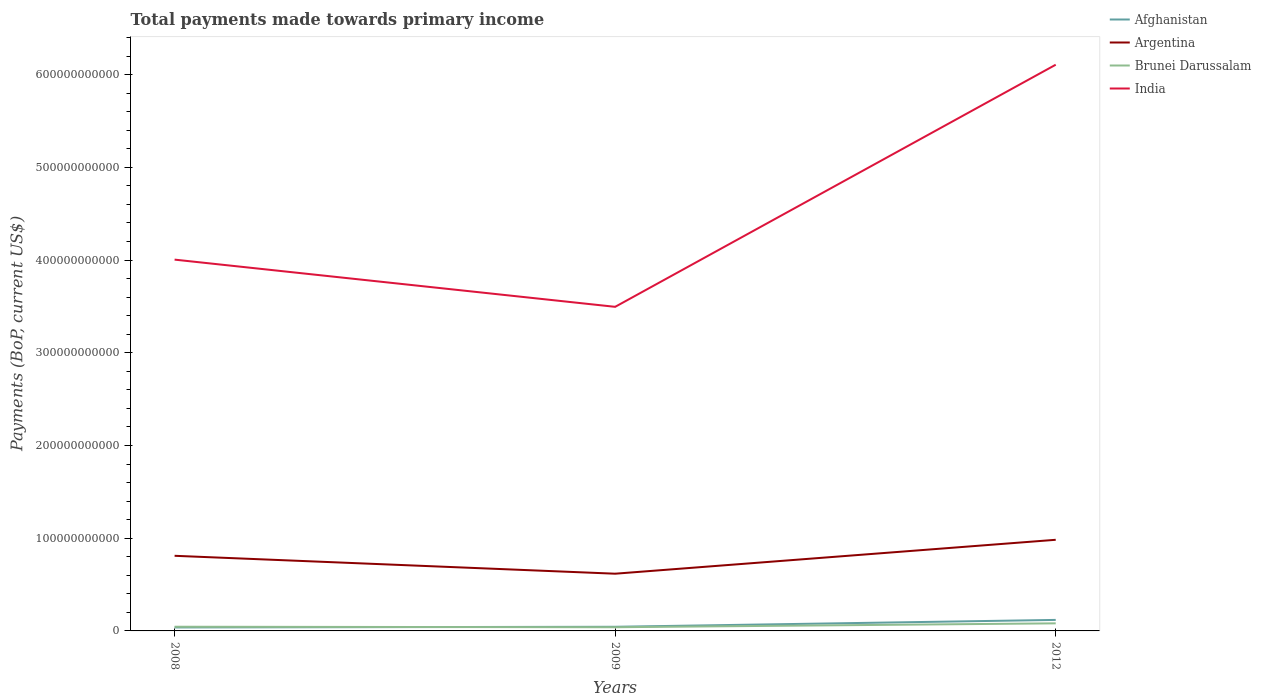How many different coloured lines are there?
Offer a terse response. 4. Across all years, what is the maximum total payments made towards primary income in India?
Give a very brief answer. 3.50e+11. In which year was the total payments made towards primary income in Afghanistan maximum?
Provide a succinct answer. 2008. What is the total total payments made towards primary income in Brunei Darussalam in the graph?
Give a very brief answer. 5.28e+08. What is the difference between the highest and the second highest total payments made towards primary income in Argentina?
Make the answer very short. 3.66e+1. What is the difference between the highest and the lowest total payments made towards primary income in Argentina?
Keep it short and to the point. 2. Is the total payments made towards primary income in India strictly greater than the total payments made towards primary income in Afghanistan over the years?
Keep it short and to the point. No. What is the difference between two consecutive major ticks on the Y-axis?
Your answer should be compact. 1.00e+11. Are the values on the major ticks of Y-axis written in scientific E-notation?
Your response must be concise. No. Does the graph contain any zero values?
Offer a terse response. No. Does the graph contain grids?
Your answer should be compact. No. Where does the legend appear in the graph?
Offer a very short reply. Top right. How many legend labels are there?
Your answer should be compact. 4. How are the legend labels stacked?
Offer a terse response. Vertical. What is the title of the graph?
Give a very brief answer. Total payments made towards primary income. Does "Belgium" appear as one of the legend labels in the graph?
Keep it short and to the point. No. What is the label or title of the X-axis?
Provide a short and direct response. Years. What is the label or title of the Y-axis?
Give a very brief answer. Payments (BoP, current US$). What is the Payments (BoP, current US$) of Afghanistan in 2008?
Keep it short and to the point. 3.75e+09. What is the Payments (BoP, current US$) in Argentina in 2008?
Make the answer very short. 8.10e+1. What is the Payments (BoP, current US$) of Brunei Darussalam in 2008?
Give a very brief answer. 4.51e+09. What is the Payments (BoP, current US$) of India in 2008?
Make the answer very short. 4.00e+11. What is the Payments (BoP, current US$) in Afghanistan in 2009?
Ensure brevity in your answer.  4.47e+09. What is the Payments (BoP, current US$) of Argentina in 2009?
Your response must be concise. 6.17e+1. What is the Payments (BoP, current US$) of Brunei Darussalam in 2009?
Your response must be concise. 3.98e+09. What is the Payments (BoP, current US$) of India in 2009?
Provide a succinct answer. 3.50e+11. What is the Payments (BoP, current US$) of Afghanistan in 2012?
Offer a terse response. 1.19e+1. What is the Payments (BoP, current US$) in Argentina in 2012?
Offer a very short reply. 9.83e+1. What is the Payments (BoP, current US$) of Brunei Darussalam in 2012?
Provide a short and direct response. 8.18e+09. What is the Payments (BoP, current US$) of India in 2012?
Provide a succinct answer. 6.11e+11. Across all years, what is the maximum Payments (BoP, current US$) in Afghanistan?
Provide a succinct answer. 1.19e+1. Across all years, what is the maximum Payments (BoP, current US$) in Argentina?
Provide a succinct answer. 9.83e+1. Across all years, what is the maximum Payments (BoP, current US$) in Brunei Darussalam?
Provide a short and direct response. 8.18e+09. Across all years, what is the maximum Payments (BoP, current US$) of India?
Ensure brevity in your answer.  6.11e+11. Across all years, what is the minimum Payments (BoP, current US$) in Afghanistan?
Make the answer very short. 3.75e+09. Across all years, what is the minimum Payments (BoP, current US$) in Argentina?
Offer a very short reply. 6.17e+1. Across all years, what is the minimum Payments (BoP, current US$) of Brunei Darussalam?
Your answer should be very brief. 3.98e+09. Across all years, what is the minimum Payments (BoP, current US$) of India?
Give a very brief answer. 3.50e+11. What is the total Payments (BoP, current US$) in Afghanistan in the graph?
Your answer should be very brief. 2.01e+1. What is the total Payments (BoP, current US$) of Argentina in the graph?
Keep it short and to the point. 2.41e+11. What is the total Payments (BoP, current US$) of Brunei Darussalam in the graph?
Give a very brief answer. 1.67e+1. What is the total Payments (BoP, current US$) in India in the graph?
Give a very brief answer. 1.36e+12. What is the difference between the Payments (BoP, current US$) of Afghanistan in 2008 and that in 2009?
Ensure brevity in your answer.  -7.15e+08. What is the difference between the Payments (BoP, current US$) in Argentina in 2008 and that in 2009?
Give a very brief answer. 1.93e+1. What is the difference between the Payments (BoP, current US$) in Brunei Darussalam in 2008 and that in 2009?
Your answer should be very brief. 5.28e+08. What is the difference between the Payments (BoP, current US$) in India in 2008 and that in 2009?
Ensure brevity in your answer.  5.09e+1. What is the difference between the Payments (BoP, current US$) in Afghanistan in 2008 and that in 2012?
Make the answer very short. -8.13e+09. What is the difference between the Payments (BoP, current US$) in Argentina in 2008 and that in 2012?
Offer a very short reply. -1.73e+1. What is the difference between the Payments (BoP, current US$) in Brunei Darussalam in 2008 and that in 2012?
Provide a succinct answer. -3.67e+09. What is the difference between the Payments (BoP, current US$) in India in 2008 and that in 2012?
Provide a short and direct response. -2.10e+11. What is the difference between the Payments (BoP, current US$) in Afghanistan in 2009 and that in 2012?
Make the answer very short. -7.42e+09. What is the difference between the Payments (BoP, current US$) of Argentina in 2009 and that in 2012?
Give a very brief answer. -3.66e+1. What is the difference between the Payments (BoP, current US$) in Brunei Darussalam in 2009 and that in 2012?
Offer a terse response. -4.20e+09. What is the difference between the Payments (BoP, current US$) of India in 2009 and that in 2012?
Provide a short and direct response. -2.61e+11. What is the difference between the Payments (BoP, current US$) of Afghanistan in 2008 and the Payments (BoP, current US$) of Argentina in 2009?
Offer a terse response. -5.80e+1. What is the difference between the Payments (BoP, current US$) in Afghanistan in 2008 and the Payments (BoP, current US$) in Brunei Darussalam in 2009?
Offer a very short reply. -2.29e+08. What is the difference between the Payments (BoP, current US$) in Afghanistan in 2008 and the Payments (BoP, current US$) in India in 2009?
Provide a succinct answer. -3.46e+11. What is the difference between the Payments (BoP, current US$) of Argentina in 2008 and the Payments (BoP, current US$) of Brunei Darussalam in 2009?
Your answer should be very brief. 7.70e+1. What is the difference between the Payments (BoP, current US$) in Argentina in 2008 and the Payments (BoP, current US$) in India in 2009?
Your answer should be compact. -2.69e+11. What is the difference between the Payments (BoP, current US$) of Brunei Darussalam in 2008 and the Payments (BoP, current US$) of India in 2009?
Make the answer very short. -3.45e+11. What is the difference between the Payments (BoP, current US$) of Afghanistan in 2008 and the Payments (BoP, current US$) of Argentina in 2012?
Provide a short and direct response. -9.45e+1. What is the difference between the Payments (BoP, current US$) in Afghanistan in 2008 and the Payments (BoP, current US$) in Brunei Darussalam in 2012?
Ensure brevity in your answer.  -4.43e+09. What is the difference between the Payments (BoP, current US$) in Afghanistan in 2008 and the Payments (BoP, current US$) in India in 2012?
Make the answer very short. -6.07e+11. What is the difference between the Payments (BoP, current US$) of Argentina in 2008 and the Payments (BoP, current US$) of Brunei Darussalam in 2012?
Ensure brevity in your answer.  7.28e+1. What is the difference between the Payments (BoP, current US$) in Argentina in 2008 and the Payments (BoP, current US$) in India in 2012?
Your answer should be very brief. -5.30e+11. What is the difference between the Payments (BoP, current US$) of Brunei Darussalam in 2008 and the Payments (BoP, current US$) of India in 2012?
Make the answer very short. -6.06e+11. What is the difference between the Payments (BoP, current US$) in Afghanistan in 2009 and the Payments (BoP, current US$) in Argentina in 2012?
Your answer should be very brief. -9.38e+1. What is the difference between the Payments (BoP, current US$) in Afghanistan in 2009 and the Payments (BoP, current US$) in Brunei Darussalam in 2012?
Make the answer very short. -3.71e+09. What is the difference between the Payments (BoP, current US$) in Afghanistan in 2009 and the Payments (BoP, current US$) in India in 2012?
Offer a very short reply. -6.06e+11. What is the difference between the Payments (BoP, current US$) in Argentina in 2009 and the Payments (BoP, current US$) in Brunei Darussalam in 2012?
Your answer should be very brief. 5.35e+1. What is the difference between the Payments (BoP, current US$) in Argentina in 2009 and the Payments (BoP, current US$) in India in 2012?
Offer a very short reply. -5.49e+11. What is the difference between the Payments (BoP, current US$) of Brunei Darussalam in 2009 and the Payments (BoP, current US$) of India in 2012?
Your answer should be compact. -6.07e+11. What is the average Payments (BoP, current US$) in Afghanistan per year?
Provide a short and direct response. 6.70e+09. What is the average Payments (BoP, current US$) in Argentina per year?
Provide a succinct answer. 8.03e+1. What is the average Payments (BoP, current US$) in Brunei Darussalam per year?
Keep it short and to the point. 5.56e+09. What is the average Payments (BoP, current US$) of India per year?
Provide a succinct answer. 4.54e+11. In the year 2008, what is the difference between the Payments (BoP, current US$) of Afghanistan and Payments (BoP, current US$) of Argentina?
Ensure brevity in your answer.  -7.73e+1. In the year 2008, what is the difference between the Payments (BoP, current US$) in Afghanistan and Payments (BoP, current US$) in Brunei Darussalam?
Offer a very short reply. -7.57e+08. In the year 2008, what is the difference between the Payments (BoP, current US$) of Afghanistan and Payments (BoP, current US$) of India?
Provide a succinct answer. -3.97e+11. In the year 2008, what is the difference between the Payments (BoP, current US$) in Argentina and Payments (BoP, current US$) in Brunei Darussalam?
Provide a short and direct response. 7.65e+1. In the year 2008, what is the difference between the Payments (BoP, current US$) in Argentina and Payments (BoP, current US$) in India?
Offer a very short reply. -3.19e+11. In the year 2008, what is the difference between the Payments (BoP, current US$) in Brunei Darussalam and Payments (BoP, current US$) in India?
Provide a short and direct response. -3.96e+11. In the year 2009, what is the difference between the Payments (BoP, current US$) of Afghanistan and Payments (BoP, current US$) of Argentina?
Provide a short and direct response. -5.72e+1. In the year 2009, what is the difference between the Payments (BoP, current US$) of Afghanistan and Payments (BoP, current US$) of Brunei Darussalam?
Provide a short and direct response. 4.86e+08. In the year 2009, what is the difference between the Payments (BoP, current US$) in Afghanistan and Payments (BoP, current US$) in India?
Keep it short and to the point. -3.45e+11. In the year 2009, what is the difference between the Payments (BoP, current US$) of Argentina and Payments (BoP, current US$) of Brunei Darussalam?
Ensure brevity in your answer.  5.77e+1. In the year 2009, what is the difference between the Payments (BoP, current US$) of Argentina and Payments (BoP, current US$) of India?
Offer a terse response. -2.88e+11. In the year 2009, what is the difference between the Payments (BoP, current US$) of Brunei Darussalam and Payments (BoP, current US$) of India?
Offer a terse response. -3.46e+11. In the year 2012, what is the difference between the Payments (BoP, current US$) in Afghanistan and Payments (BoP, current US$) in Argentina?
Offer a very short reply. -8.64e+1. In the year 2012, what is the difference between the Payments (BoP, current US$) in Afghanistan and Payments (BoP, current US$) in Brunei Darussalam?
Offer a very short reply. 3.71e+09. In the year 2012, what is the difference between the Payments (BoP, current US$) in Afghanistan and Payments (BoP, current US$) in India?
Provide a succinct answer. -5.99e+11. In the year 2012, what is the difference between the Payments (BoP, current US$) of Argentina and Payments (BoP, current US$) of Brunei Darussalam?
Your answer should be compact. 9.01e+1. In the year 2012, what is the difference between the Payments (BoP, current US$) of Argentina and Payments (BoP, current US$) of India?
Offer a very short reply. -5.12e+11. In the year 2012, what is the difference between the Payments (BoP, current US$) in Brunei Darussalam and Payments (BoP, current US$) in India?
Give a very brief answer. -6.02e+11. What is the ratio of the Payments (BoP, current US$) of Afghanistan in 2008 to that in 2009?
Your response must be concise. 0.84. What is the ratio of the Payments (BoP, current US$) of Argentina in 2008 to that in 2009?
Provide a succinct answer. 1.31. What is the ratio of the Payments (BoP, current US$) of Brunei Darussalam in 2008 to that in 2009?
Provide a short and direct response. 1.13. What is the ratio of the Payments (BoP, current US$) in India in 2008 to that in 2009?
Offer a terse response. 1.15. What is the ratio of the Payments (BoP, current US$) in Afghanistan in 2008 to that in 2012?
Offer a terse response. 0.32. What is the ratio of the Payments (BoP, current US$) of Argentina in 2008 to that in 2012?
Your answer should be compact. 0.82. What is the ratio of the Payments (BoP, current US$) in Brunei Darussalam in 2008 to that in 2012?
Give a very brief answer. 0.55. What is the ratio of the Payments (BoP, current US$) in India in 2008 to that in 2012?
Offer a very short reply. 0.66. What is the ratio of the Payments (BoP, current US$) in Afghanistan in 2009 to that in 2012?
Offer a terse response. 0.38. What is the ratio of the Payments (BoP, current US$) in Argentina in 2009 to that in 2012?
Ensure brevity in your answer.  0.63. What is the ratio of the Payments (BoP, current US$) of Brunei Darussalam in 2009 to that in 2012?
Ensure brevity in your answer.  0.49. What is the ratio of the Payments (BoP, current US$) of India in 2009 to that in 2012?
Offer a very short reply. 0.57. What is the difference between the highest and the second highest Payments (BoP, current US$) in Afghanistan?
Your answer should be very brief. 7.42e+09. What is the difference between the highest and the second highest Payments (BoP, current US$) of Argentina?
Your response must be concise. 1.73e+1. What is the difference between the highest and the second highest Payments (BoP, current US$) of Brunei Darussalam?
Your answer should be very brief. 3.67e+09. What is the difference between the highest and the second highest Payments (BoP, current US$) in India?
Give a very brief answer. 2.10e+11. What is the difference between the highest and the lowest Payments (BoP, current US$) of Afghanistan?
Keep it short and to the point. 8.13e+09. What is the difference between the highest and the lowest Payments (BoP, current US$) in Argentina?
Offer a very short reply. 3.66e+1. What is the difference between the highest and the lowest Payments (BoP, current US$) in Brunei Darussalam?
Keep it short and to the point. 4.20e+09. What is the difference between the highest and the lowest Payments (BoP, current US$) in India?
Ensure brevity in your answer.  2.61e+11. 